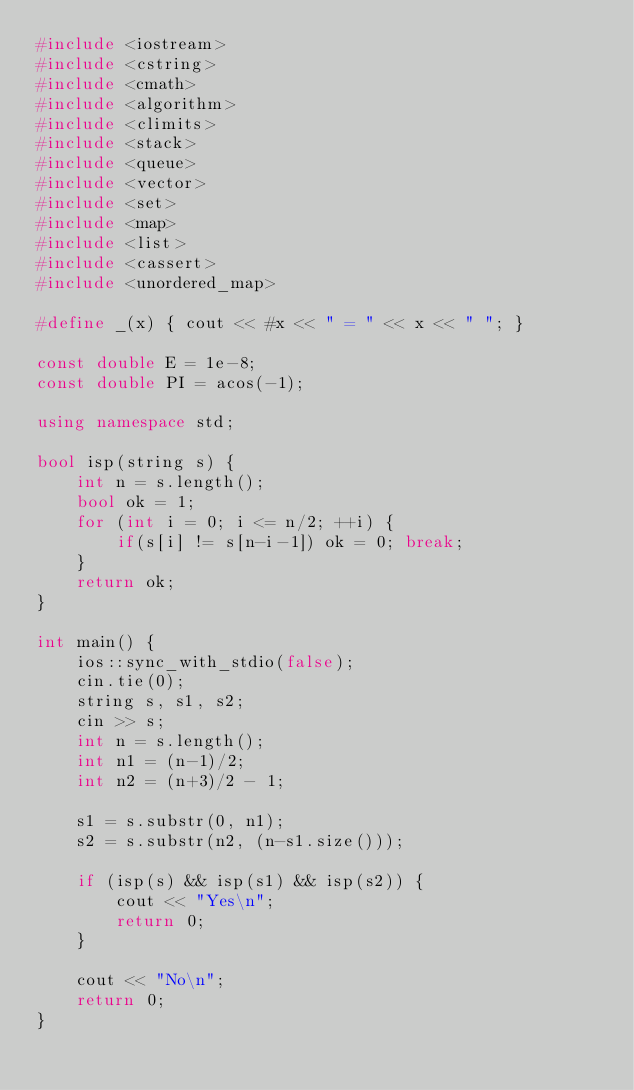<code> <loc_0><loc_0><loc_500><loc_500><_C++_>#include <iostream>
#include <cstring>
#include <cmath>
#include <algorithm>
#include <climits>
#include <stack>
#include <queue>
#include <vector>
#include <set>
#include <map>
#include <list>
#include <cassert>
#include <unordered_map>

#define _(x) { cout << #x << " = " << x << " "; }

const double E = 1e-8;
const double PI = acos(-1);

using namespace std;

bool isp(string s) {
    int n = s.length();
    bool ok = 1;
    for (int i = 0; i <= n/2; ++i) {
        if(s[i] != s[n-i-1]) ok = 0; break;
    }
    return ok;
}

int main() {
    ios::sync_with_stdio(false);
    cin.tie(0);
    string s, s1, s2;
    cin >> s;
    int n = s.length();
    int n1 = (n-1)/2; 
    int n2 = (n+3)/2 - 1;

    s1 = s.substr(0, n1);
    s2 = s.substr(n2, (n-s1.size()));

    if (isp(s) && isp(s1) && isp(s2)) {
        cout << "Yes\n";
        return 0;
    }

    cout << "No\n";
    return 0;
}

</code> 